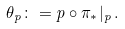Convert formula to latex. <formula><loc_0><loc_0><loc_500><loc_500>\theta _ { p } \colon = p \circ \pi _ { * } | _ { p } \, .</formula> 